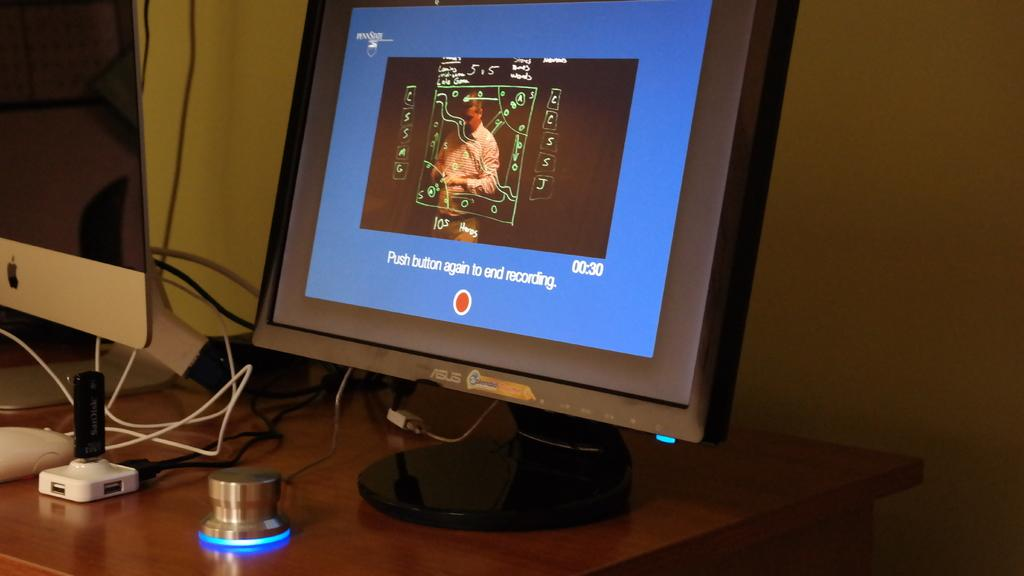<image>
Render a clear and concise summary of the photo. A computer screen shows a message about pushing a button to stop recording. 